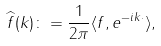<formula> <loc_0><loc_0><loc_500><loc_500>\widehat { f } ( k ) \colon = \frac { 1 } { 2 \pi } \langle f , e ^ { - i k \cdot } \rangle ,</formula> 